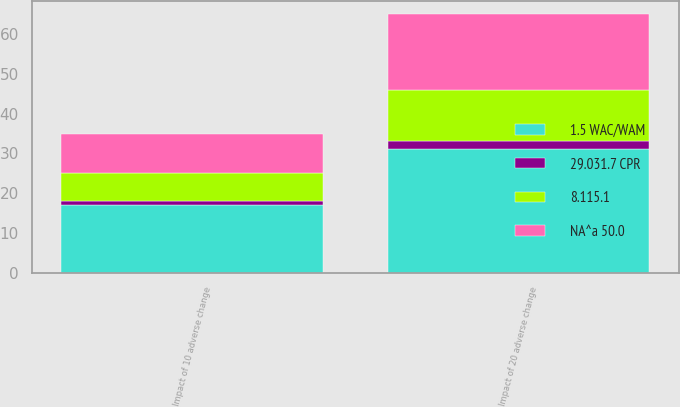Convert chart. <chart><loc_0><loc_0><loc_500><loc_500><stacked_bar_chart><ecel><fcel>Impact of 10 adverse change<fcel>Impact of 20 adverse change<nl><fcel>1.5 WAC/WAM<fcel>17<fcel>31<nl><fcel>8.115.1<fcel>7<fcel>13<nl><fcel>NA^a 50.0<fcel>10<fcel>19<nl><fcel>29.031.7 CPR<fcel>1<fcel>2<nl></chart> 